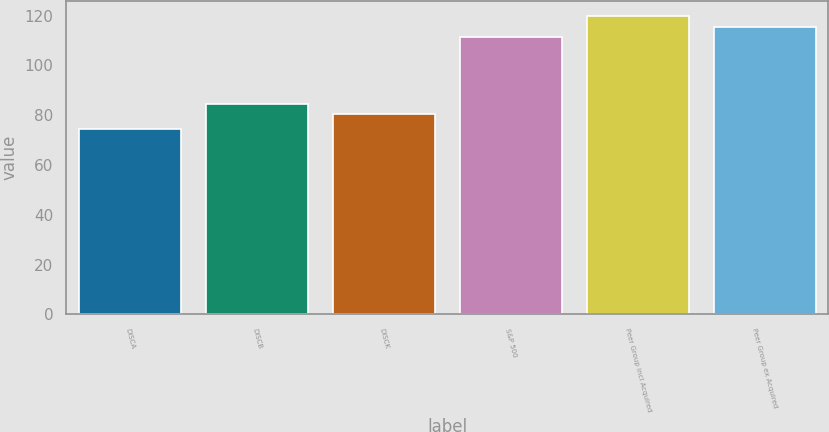<chart> <loc_0><loc_0><loc_500><loc_500><bar_chart><fcel>DISCA<fcel>DISCB<fcel>DISCK<fcel>S&P 500<fcel>Peer Group incl Acquired<fcel>Peer Group ex Acquired<nl><fcel>74.58<fcel>84.63<fcel>80.42<fcel>111.39<fcel>119.81<fcel>115.6<nl></chart> 